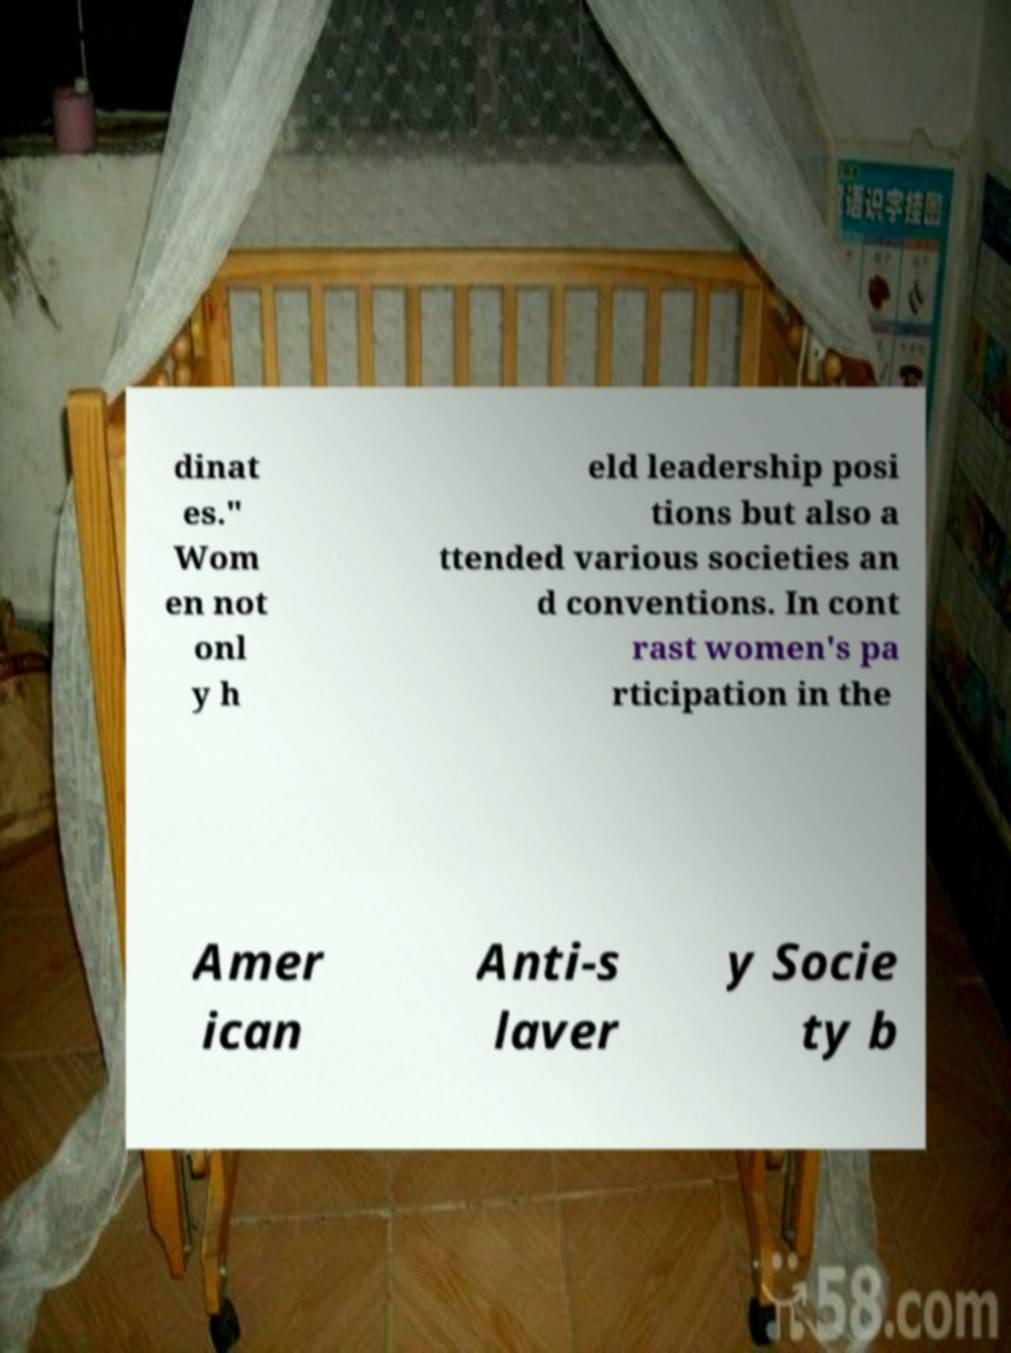There's text embedded in this image that I need extracted. Can you transcribe it verbatim? dinat es." Wom en not onl y h eld leadership posi tions but also a ttended various societies an d conventions. In cont rast women's pa rticipation in the Amer ican Anti-s laver y Socie ty b 